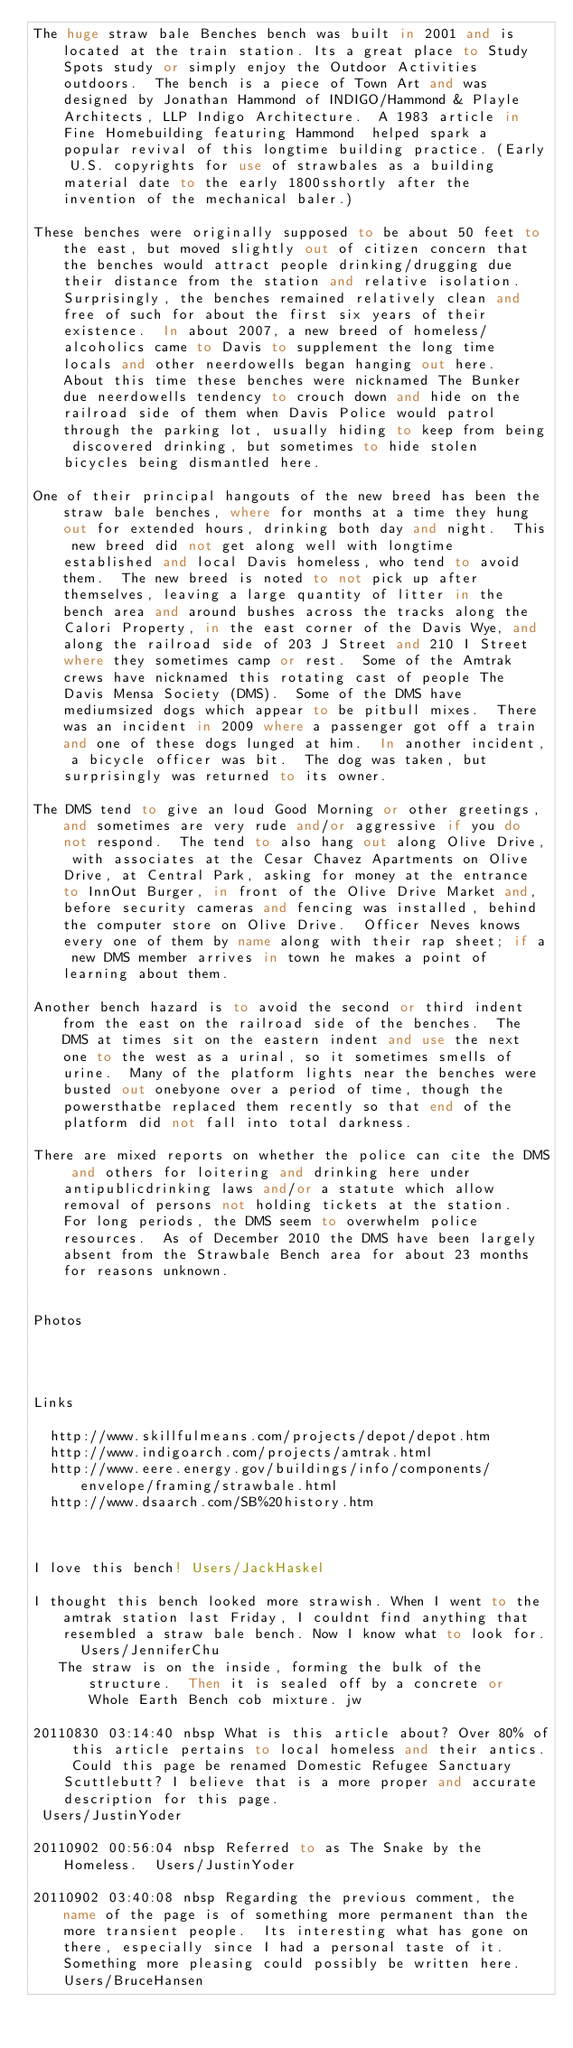Convert code to text. <code><loc_0><loc_0><loc_500><loc_500><_FORTRAN_>The huge straw bale Benches bench was built in 2001 and is located at the train station. Its a great place to Study Spots study or simply enjoy the Outdoor Activities outdoors.  The bench is a piece of Town Art and was designed by Jonathan Hammond of INDIGO/Hammond & Playle Architects, LLP Indigo Architecture.  A 1983 article in Fine Homebuilding featuring Hammond  helped spark a popular revival of this longtime building practice. (Early U.S. copyrights for use of strawbales as a building material date to the early 1800sshortly after the invention of the mechanical baler.)

These benches were originally supposed to be about 50 feet to the east, but moved slightly out of citizen concern that the benches would attract people drinking/drugging due their distance from the station and relative isolation.  Surprisingly, the benches remained relatively clean and free of such for about the first six years of their existence.  In about 2007, a new breed of homeless/alcoholics came to Davis to supplement the long time locals and other neerdowells began hanging out here.  About this time these benches were nicknamed The Bunker due neerdowells tendency to crouch down and hide on the railroad side of them when Davis Police would patrol through the parking lot, usually hiding to keep from being discovered drinking, but sometimes to hide stolen bicycles being dismantled here.

One of their principal hangouts of the new breed has been the straw bale benches, where for months at a time they hung out for extended hours, drinking both day and night.  This new breed did not get along well with longtime established and local Davis homeless, who tend to avoid them.  The new breed is noted to not pick up after themselves, leaving a large quantity of litter in the bench area and around bushes across the tracks along the Calori Property, in the east corner of the Davis Wye, and along the railroad side of 203 J Street and 210 I Street where they sometimes camp or rest.  Some of the Amtrak crews have nicknamed this rotating cast of people The Davis Mensa Society (DMS).  Some of the DMS have mediumsized dogs which appear to be pitbull mixes.  There was an incident in 2009 where a passenger got off a train and one of these dogs lunged at him.  In another incident, a bicycle officer was bit.  The dog was taken, but surprisingly was returned to its owner.

The DMS tend to give an loud Good Morning or other greetings, and sometimes are very rude and/or aggressive if you do not respond.  The tend to also hang out along Olive Drive, with associates at the Cesar Chavez Apartments on Olive Drive, at Central Park, asking for money at the entrance to InnOut Burger, in front of the Olive Drive Market and, before security cameras and fencing was installed, behind the computer store on Olive Drive.  Officer Neves knows every one of them by name along with their rap sheet; if a new DMS member arrives in town he makes a point of learning about them.

Another bench hazard is to avoid the second or third indent from the east on the railroad side of the benches.  The DMS at times sit on the eastern indent and use the next one to the west as a urinal, so it sometimes smells of urine.  Many of the platform lights near the benches were busted out onebyone over a period of time, though the powersthatbe replaced them recently so that end of the platform did not fall into total darkness.

There are mixed reports on whether the police can cite the DMS and others for loitering and drinking here under antipublicdrinking laws and/or a statute which allow removal of persons not holding tickets at the station.  For long periods, the DMS seem to overwhelm police resources.  As of December 2010 the DMS have been largely absent from the Strawbale Bench area for about 23 months for reasons unknown.


Photos




Links

  http://www.skillfulmeans.com/projects/depot/depot.htm
  http://www.indigoarch.com/projects/amtrak.html
  http://www.eere.energy.gov/buildings/info/components/envelope/framing/strawbale.html
  http://www.dsaarch.com/SB%20history.htm



I love this bench! Users/JackHaskel

I thought this bench looked more strawish. When I went to the amtrak station last Friday, I couldnt find anything that resembled a straw bale bench. Now I know what to look for.  Users/JenniferChu
   The straw is on the inside, forming the bulk of the structure.  Then it is sealed off by a concrete or Whole Earth Bench cob mixture. jw

20110830 03:14:40 nbsp What is this article about? Over 80% of this article pertains to local homeless and their antics. Could this page be renamed Domestic Refugee Sanctuary Scuttlebutt? I believe that is a more proper and accurate description for this page.
 Users/JustinYoder

20110902 00:56:04 nbsp Referred to as The Snake by the Homeless.  Users/JustinYoder

20110902 03:40:08 nbsp Regarding the previous comment, the name of the page is of something more permanent than the more transient people.  Its interesting what has gone on there, especially since I had a personal taste of it.  Something more pleasing could possibly be written here. Users/BruceHansen
</code> 